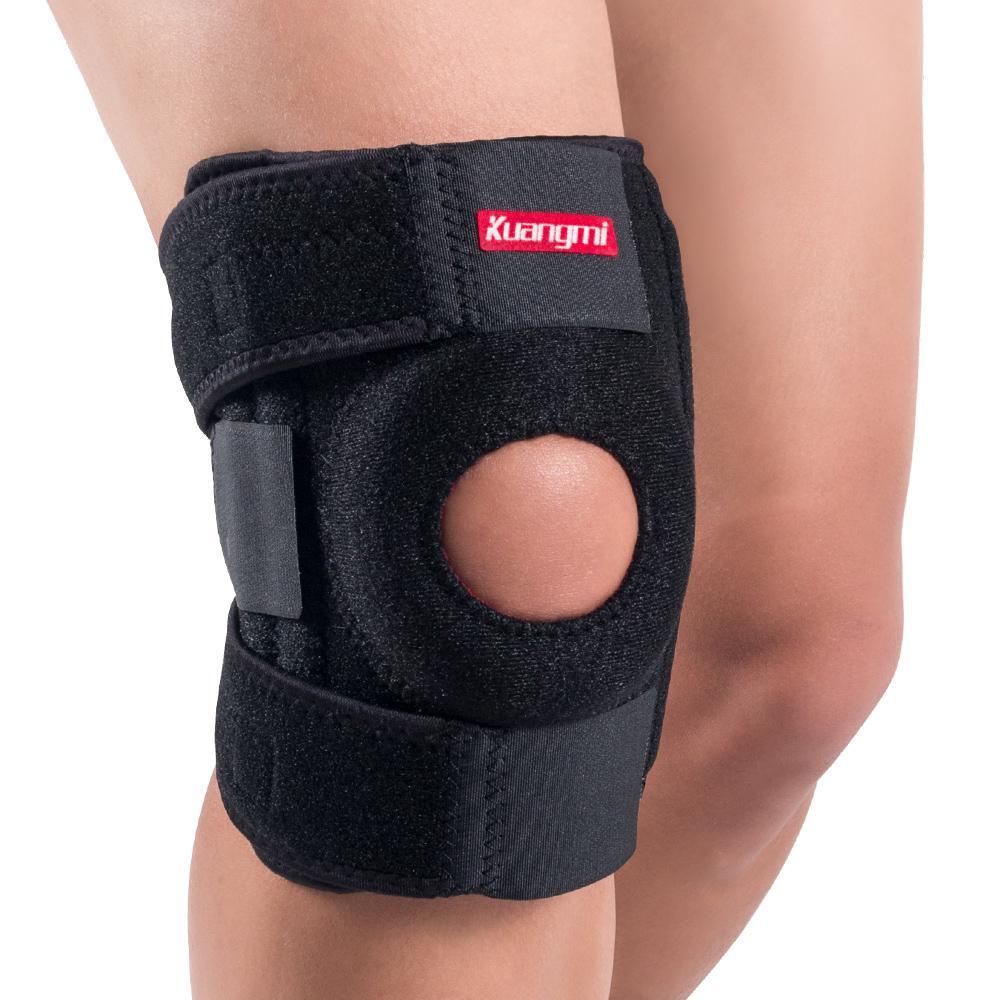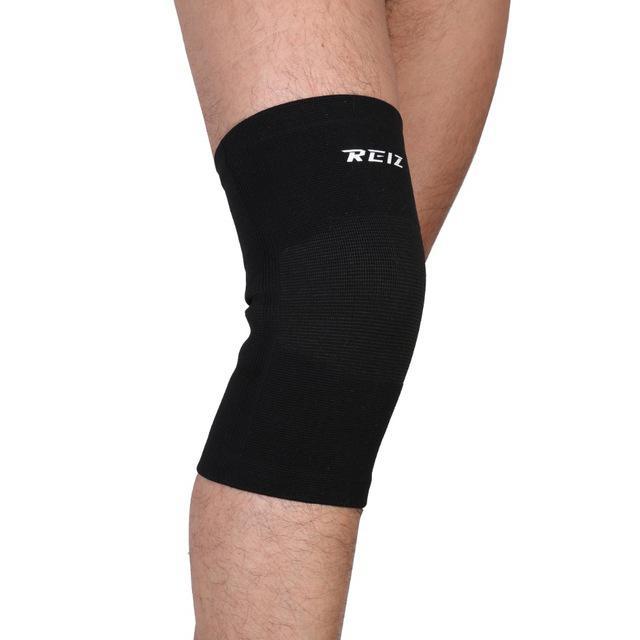The first image is the image on the left, the second image is the image on the right. Analyze the images presented: Is the assertion "One of the knee-pads has Velcro around the top and one does not." valid? Answer yes or no. Yes. 